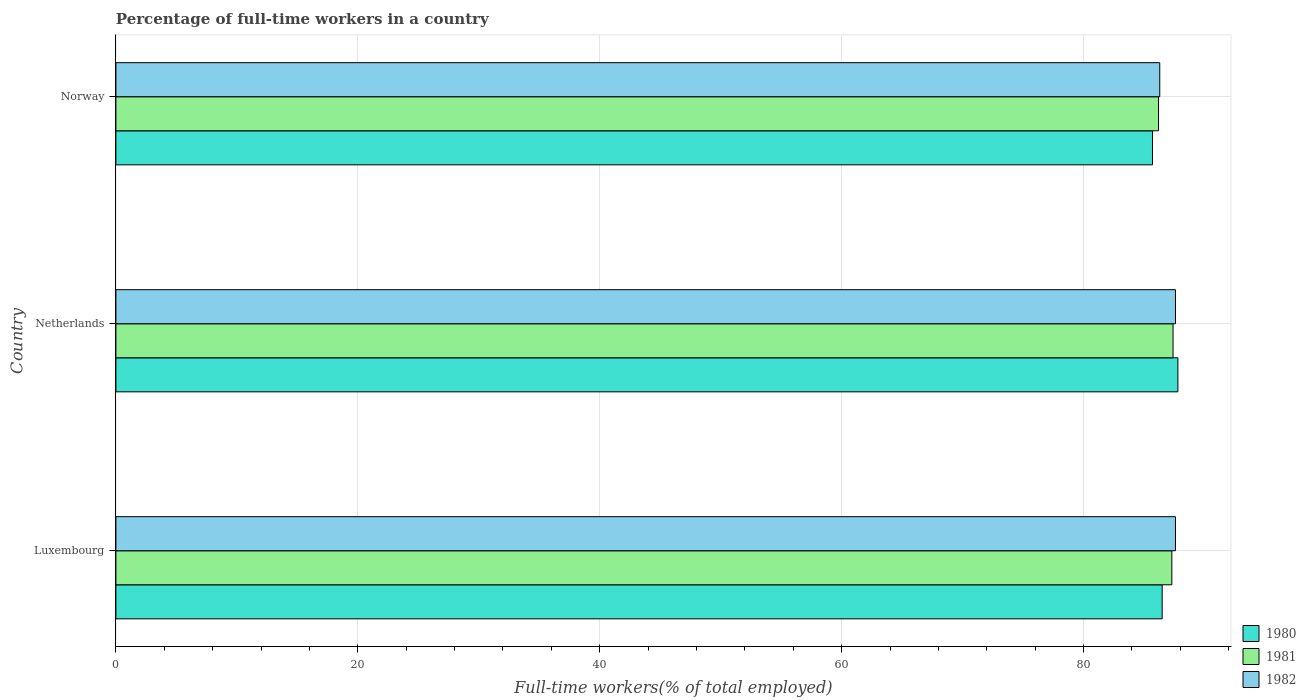Are the number of bars per tick equal to the number of legend labels?
Give a very brief answer. Yes. How many bars are there on the 3rd tick from the top?
Ensure brevity in your answer.  3. What is the label of the 2nd group of bars from the top?
Offer a terse response. Netherlands. In how many cases, is the number of bars for a given country not equal to the number of legend labels?
Offer a very short reply. 0. What is the percentage of full-time workers in 1980 in Norway?
Ensure brevity in your answer.  85.7. Across all countries, what is the maximum percentage of full-time workers in 1980?
Your answer should be compact. 87.8. Across all countries, what is the minimum percentage of full-time workers in 1980?
Your answer should be compact. 85.7. What is the total percentage of full-time workers in 1981 in the graph?
Provide a short and direct response. 260.9. What is the difference between the percentage of full-time workers in 1980 in Netherlands and that in Norway?
Ensure brevity in your answer.  2.1. What is the average percentage of full-time workers in 1981 per country?
Keep it short and to the point. 86.97. What is the difference between the percentage of full-time workers in 1982 and percentage of full-time workers in 1981 in Norway?
Ensure brevity in your answer.  0.1. What is the ratio of the percentage of full-time workers in 1982 in Netherlands to that in Norway?
Make the answer very short. 1.02. What is the difference between the highest and the second highest percentage of full-time workers in 1981?
Give a very brief answer. 0.1. What is the difference between the highest and the lowest percentage of full-time workers in 1980?
Offer a terse response. 2.1. In how many countries, is the percentage of full-time workers in 1981 greater than the average percentage of full-time workers in 1981 taken over all countries?
Make the answer very short. 2. Is the sum of the percentage of full-time workers in 1980 in Luxembourg and Norway greater than the maximum percentage of full-time workers in 1982 across all countries?
Your response must be concise. Yes. How many bars are there?
Offer a very short reply. 9. Are all the bars in the graph horizontal?
Make the answer very short. Yes. Are the values on the major ticks of X-axis written in scientific E-notation?
Make the answer very short. No. Does the graph contain any zero values?
Offer a terse response. No. Does the graph contain grids?
Give a very brief answer. Yes. How many legend labels are there?
Ensure brevity in your answer.  3. What is the title of the graph?
Offer a very short reply. Percentage of full-time workers in a country. Does "1960" appear as one of the legend labels in the graph?
Keep it short and to the point. No. What is the label or title of the X-axis?
Provide a succinct answer. Full-time workers(% of total employed). What is the Full-time workers(% of total employed) in 1980 in Luxembourg?
Offer a very short reply. 86.5. What is the Full-time workers(% of total employed) of 1981 in Luxembourg?
Offer a very short reply. 87.3. What is the Full-time workers(% of total employed) of 1982 in Luxembourg?
Give a very brief answer. 87.6. What is the Full-time workers(% of total employed) in 1980 in Netherlands?
Your answer should be very brief. 87.8. What is the Full-time workers(% of total employed) of 1981 in Netherlands?
Your answer should be compact. 87.4. What is the Full-time workers(% of total employed) in 1982 in Netherlands?
Offer a terse response. 87.6. What is the Full-time workers(% of total employed) in 1980 in Norway?
Keep it short and to the point. 85.7. What is the Full-time workers(% of total employed) of 1981 in Norway?
Your answer should be compact. 86.2. What is the Full-time workers(% of total employed) in 1982 in Norway?
Your answer should be compact. 86.3. Across all countries, what is the maximum Full-time workers(% of total employed) in 1980?
Make the answer very short. 87.8. Across all countries, what is the maximum Full-time workers(% of total employed) in 1981?
Make the answer very short. 87.4. Across all countries, what is the maximum Full-time workers(% of total employed) of 1982?
Offer a very short reply. 87.6. Across all countries, what is the minimum Full-time workers(% of total employed) of 1980?
Provide a succinct answer. 85.7. Across all countries, what is the minimum Full-time workers(% of total employed) of 1981?
Keep it short and to the point. 86.2. Across all countries, what is the minimum Full-time workers(% of total employed) of 1982?
Give a very brief answer. 86.3. What is the total Full-time workers(% of total employed) in 1980 in the graph?
Your response must be concise. 260. What is the total Full-time workers(% of total employed) of 1981 in the graph?
Offer a terse response. 260.9. What is the total Full-time workers(% of total employed) of 1982 in the graph?
Ensure brevity in your answer.  261.5. What is the difference between the Full-time workers(% of total employed) of 1980 in Luxembourg and that in Norway?
Provide a succinct answer. 0.8. What is the difference between the Full-time workers(% of total employed) in 1980 in Netherlands and that in Norway?
Offer a terse response. 2.1. What is the difference between the Full-time workers(% of total employed) of 1981 in Netherlands and that in Norway?
Your response must be concise. 1.2. What is the difference between the Full-time workers(% of total employed) of 1982 in Netherlands and that in Norway?
Offer a terse response. 1.3. What is the difference between the Full-time workers(% of total employed) in 1980 in Luxembourg and the Full-time workers(% of total employed) in 1982 in Netherlands?
Offer a terse response. -1.1. What is the difference between the Full-time workers(% of total employed) of 1981 in Luxembourg and the Full-time workers(% of total employed) of 1982 in Netherlands?
Offer a very short reply. -0.3. What is the difference between the Full-time workers(% of total employed) in 1981 in Luxembourg and the Full-time workers(% of total employed) in 1982 in Norway?
Keep it short and to the point. 1. What is the difference between the Full-time workers(% of total employed) of 1980 in Netherlands and the Full-time workers(% of total employed) of 1981 in Norway?
Your response must be concise. 1.6. What is the average Full-time workers(% of total employed) of 1980 per country?
Provide a short and direct response. 86.67. What is the average Full-time workers(% of total employed) in 1981 per country?
Keep it short and to the point. 86.97. What is the average Full-time workers(% of total employed) of 1982 per country?
Your answer should be very brief. 87.17. What is the difference between the Full-time workers(% of total employed) in 1980 and Full-time workers(% of total employed) in 1982 in Luxembourg?
Keep it short and to the point. -1.1. What is the difference between the Full-time workers(% of total employed) of 1980 and Full-time workers(% of total employed) of 1981 in Norway?
Your answer should be very brief. -0.5. What is the difference between the Full-time workers(% of total employed) in 1981 and Full-time workers(% of total employed) in 1982 in Norway?
Offer a terse response. -0.1. What is the ratio of the Full-time workers(% of total employed) of 1980 in Luxembourg to that in Netherlands?
Ensure brevity in your answer.  0.99. What is the ratio of the Full-time workers(% of total employed) of 1980 in Luxembourg to that in Norway?
Make the answer very short. 1.01. What is the ratio of the Full-time workers(% of total employed) of 1981 in Luxembourg to that in Norway?
Provide a succinct answer. 1.01. What is the ratio of the Full-time workers(% of total employed) of 1982 in Luxembourg to that in Norway?
Give a very brief answer. 1.02. What is the ratio of the Full-time workers(% of total employed) in 1980 in Netherlands to that in Norway?
Your answer should be compact. 1.02. What is the ratio of the Full-time workers(% of total employed) of 1981 in Netherlands to that in Norway?
Offer a terse response. 1.01. What is the ratio of the Full-time workers(% of total employed) in 1982 in Netherlands to that in Norway?
Keep it short and to the point. 1.02. What is the difference between the highest and the second highest Full-time workers(% of total employed) of 1980?
Offer a very short reply. 1.3. What is the difference between the highest and the lowest Full-time workers(% of total employed) of 1980?
Your response must be concise. 2.1. What is the difference between the highest and the lowest Full-time workers(% of total employed) in 1981?
Provide a short and direct response. 1.2. What is the difference between the highest and the lowest Full-time workers(% of total employed) of 1982?
Your answer should be compact. 1.3. 